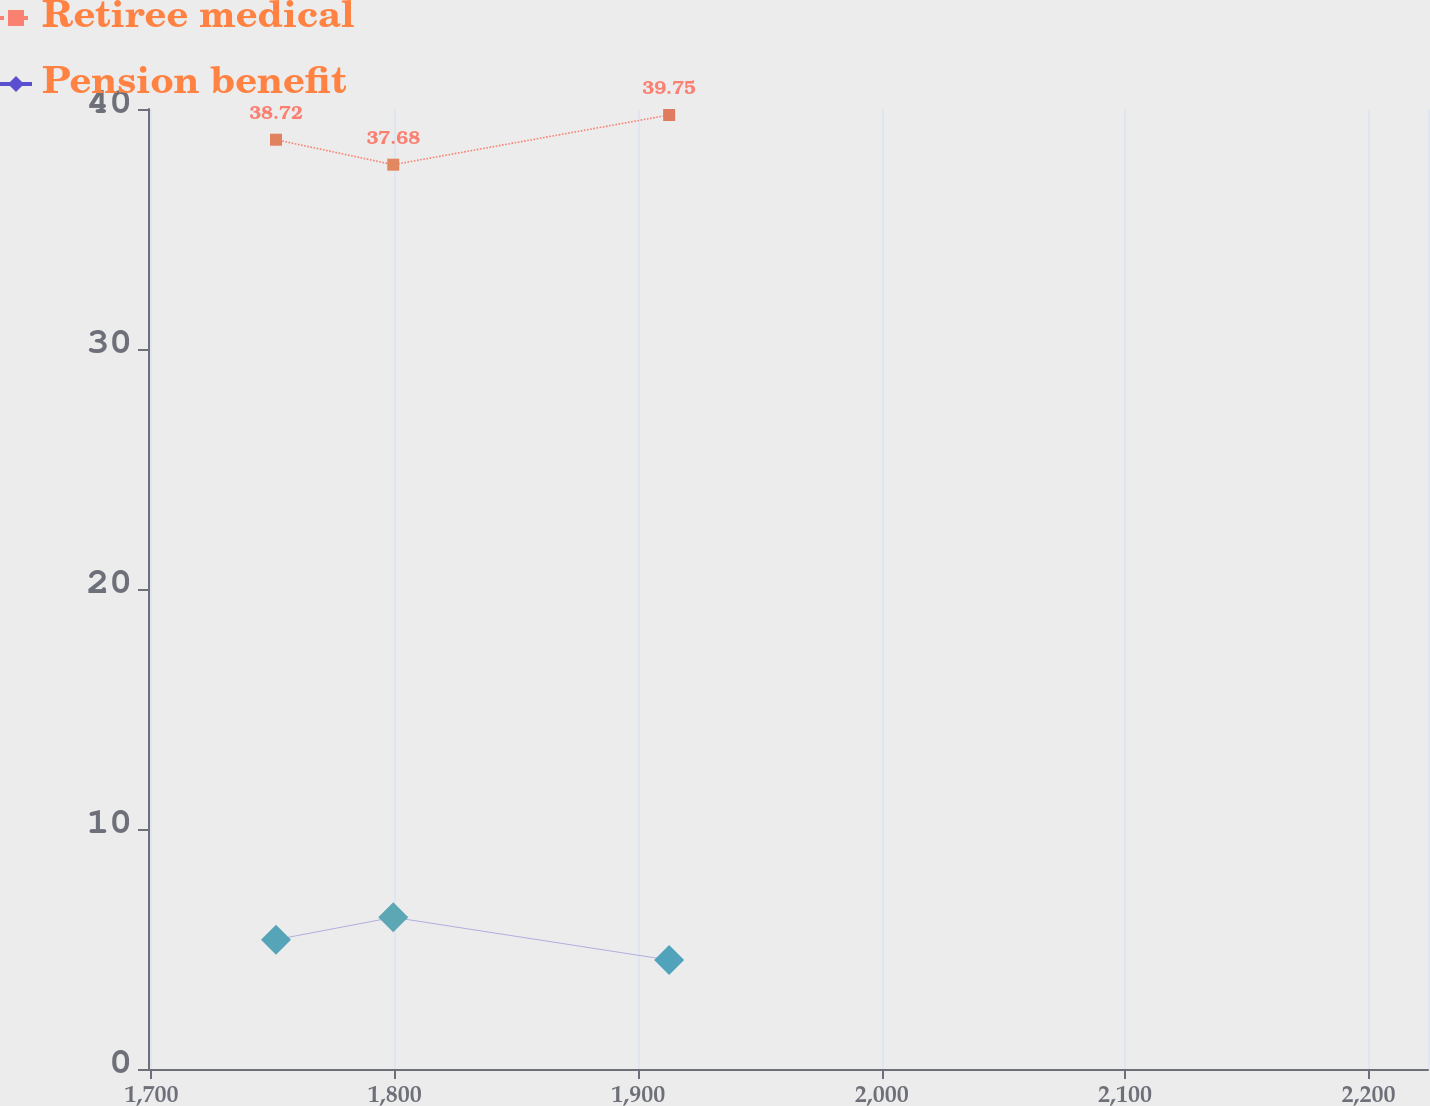<chart> <loc_0><loc_0><loc_500><loc_500><line_chart><ecel><fcel>Retiree medical<fcel>Pension benefit<nl><fcel>1751.17<fcel>38.72<fcel>5.39<nl><fcel>1799.34<fcel>37.68<fcel>6.32<nl><fcel>1912.7<fcel>39.75<fcel>4.54<nl><fcel>2228.9<fcel>48.03<fcel>6.96<nl><fcel>2277.07<fcel>43.04<fcel>5.63<nl></chart> 